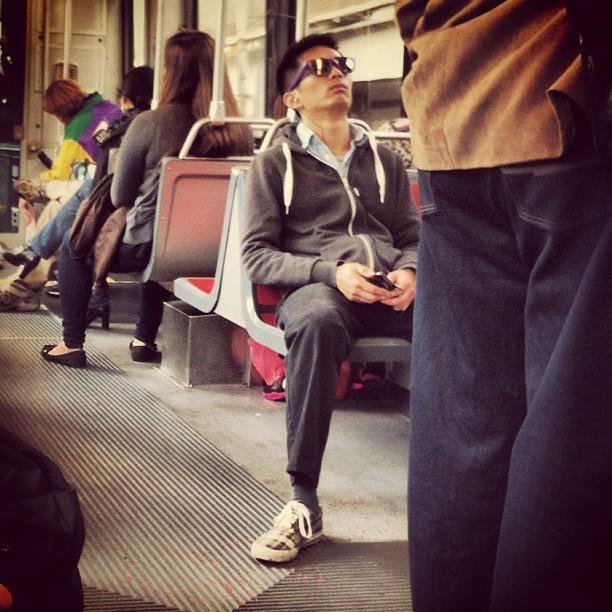How many chairs are in the photo?
Give a very brief answer. 3. How many people are there?
Give a very brief answer. 5. How many of the train cars can you see someone sticking their head out of?
Give a very brief answer. 0. 